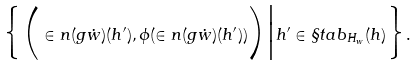Convert formula to latex. <formula><loc_0><loc_0><loc_500><loc_500>\Big \{ \Big ( \in n ( g \dot { w } ) ( h ^ { \prime } ) , \phi ( \in n ( g \dot { w } ) ( h ^ { \prime } ) ) \Big ) \Big | h ^ { \prime } \in \S t a b _ { H _ { w } } ( h ) \Big \} .</formula> 